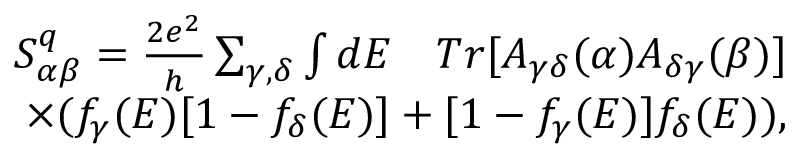<formula> <loc_0><loc_0><loc_500><loc_500>\begin{array} { r } { S _ { \alpha \beta } ^ { q } = \frac { 2 e ^ { 2 } } { h } \sum _ { \gamma , \delta } \int d E \quad T r [ A _ { \gamma \delta } ( \alpha ) A _ { \delta \gamma } ( \beta ) ] } \\ { \times ( f _ { \gamma } ( E ) [ 1 - f _ { \delta } ( E ) ] + [ 1 - f _ { \gamma } ( E ) ] f _ { \delta } ( E ) ) , } \end{array}</formula> 